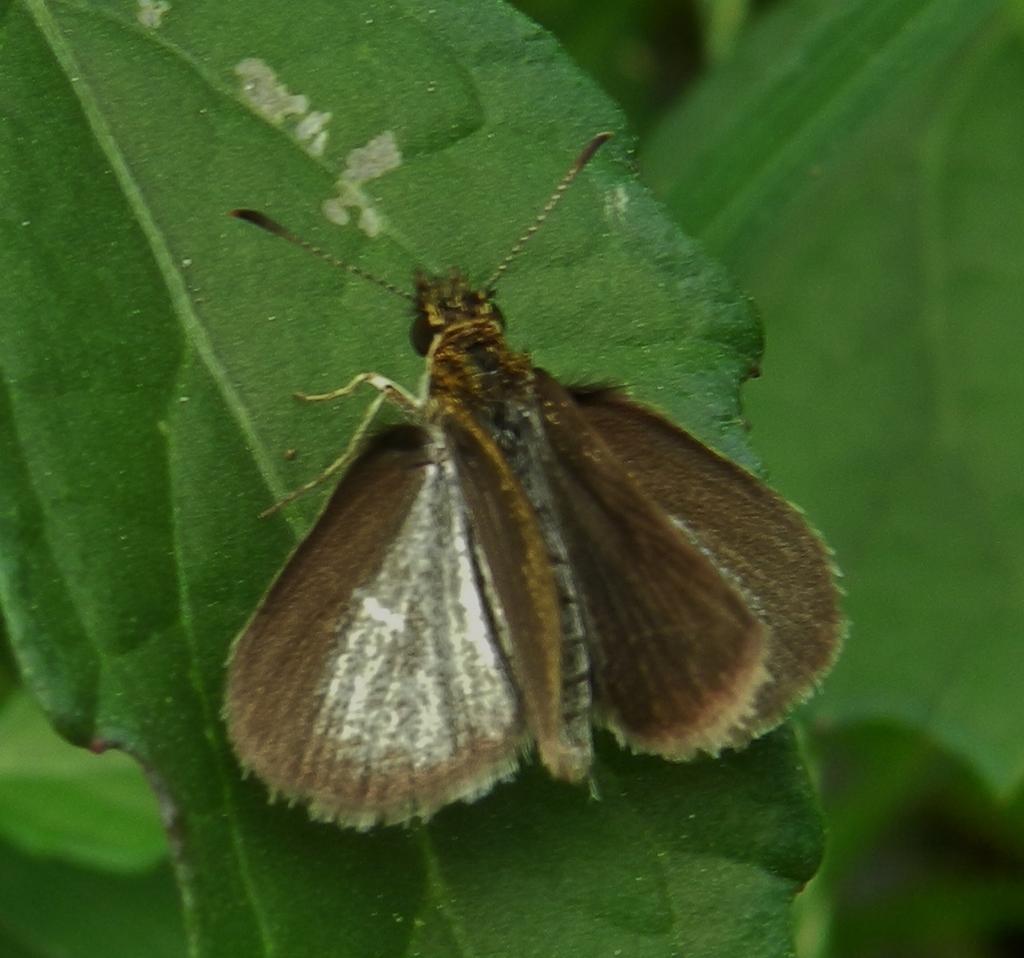Could you give a brief overview of what you see in this image? In this picture, we see an insect is on the green leaf. This insect looks like a butterfly and it is in brown color. In the background, it is in green color. This picture is blurred in the background. 